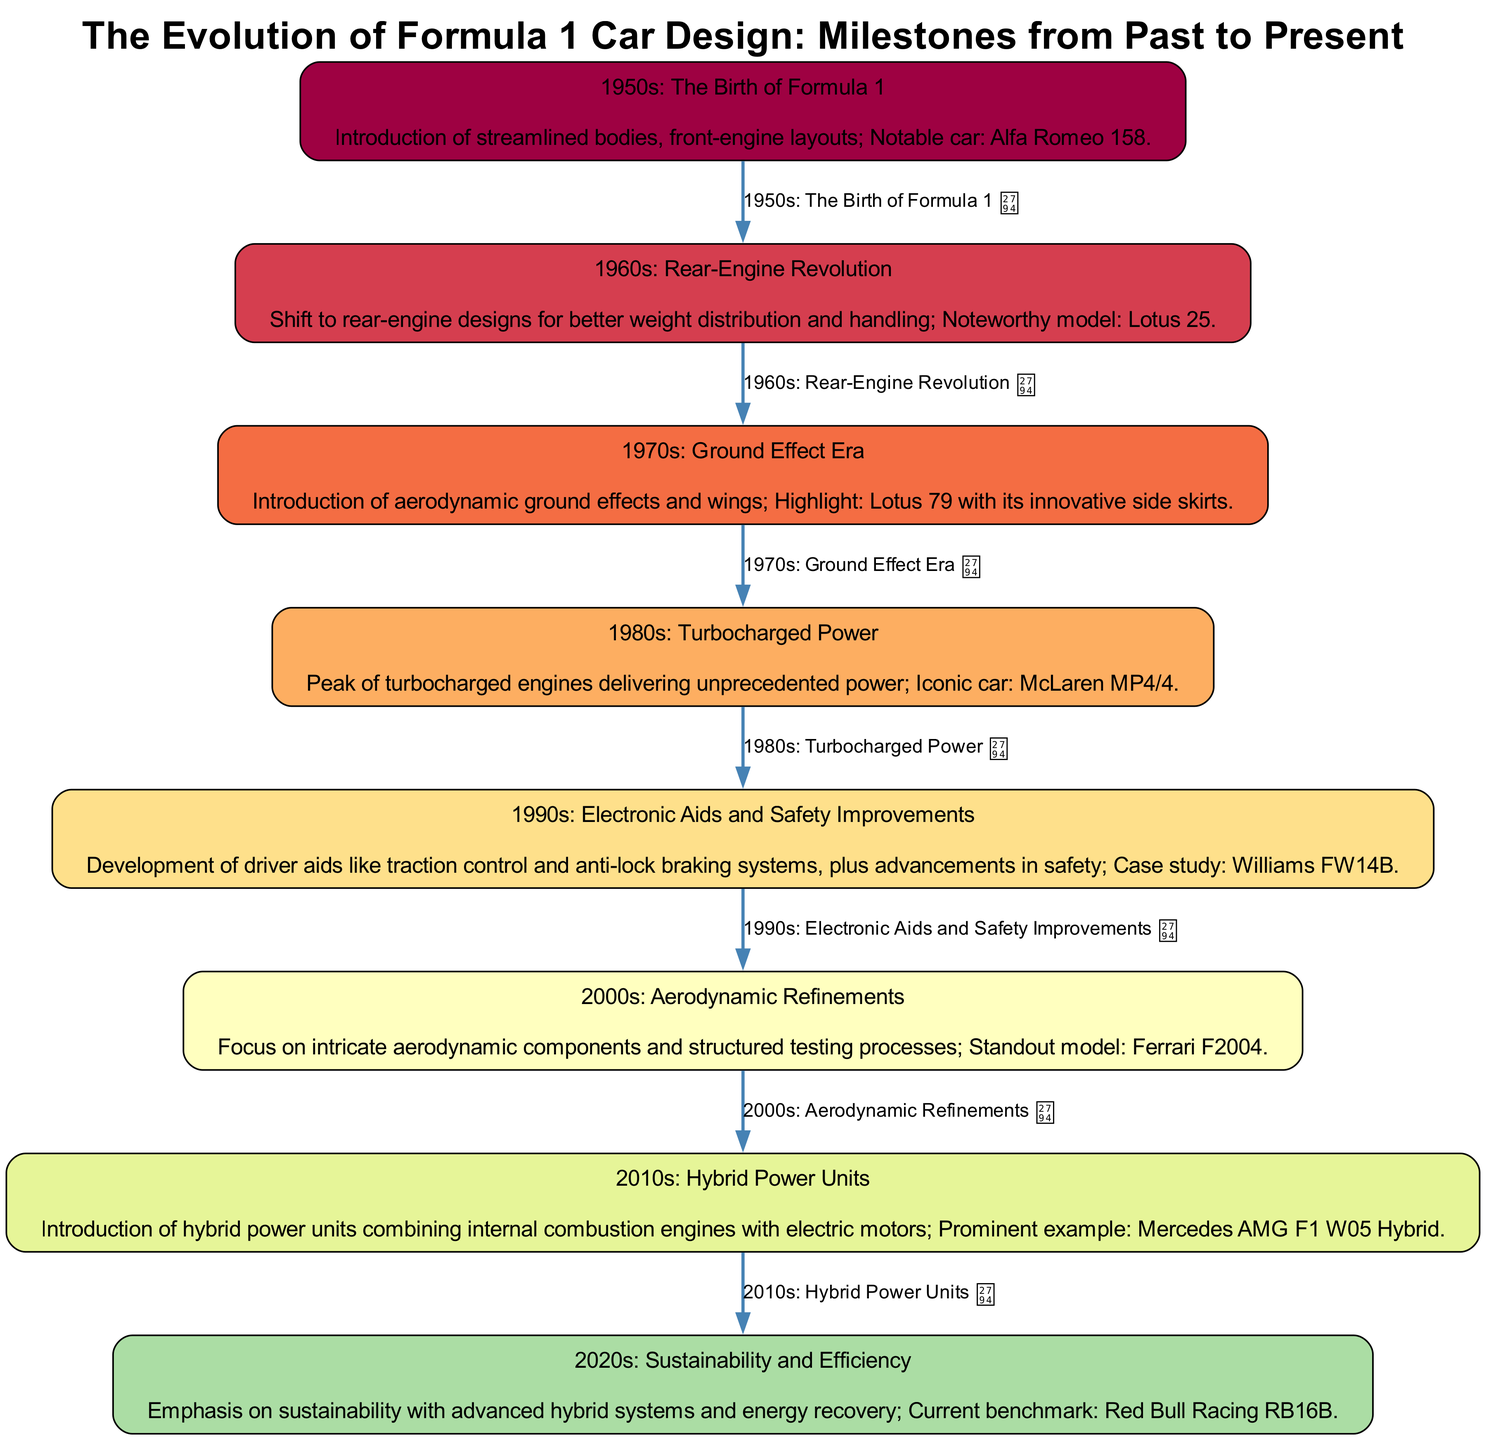What's the first milestone in the evolution of Formula 1 car design? The first milestone is the "1950s: The Birth of Formula 1," which introduces streamlined bodies and front-engine layouts, exemplified by the Alfa Romeo 158.
Answer: 1950s: The Birth of Formula 1 How many milestones are presented in the diagram? The diagram presents a total of eight milestones that outline the evolution of Formula 1 car design from the 1950s to the 2020s.
Answer: Eight Which car is highlighted for the 1970s? The highlighted car for the 1970s is the Lotus 79, known for its innovative aerodynamic side skirts that contributed to the ground effect era.
Answer: Lotus 79 What change occurred in the 2010s regarding engine technology? In the 2010s, the introduction of hybrid power units combined internal combustion engines with electric motors.
Answer: Hybrid power units Which decade introduced turbocharged engines? The 1980s introduced turbocharged engines, showcasing unprecedented power in Formula 1 cars, notably with the McLaren MP4/4.
Answer: 1980s What is the key feature of the 1990s Formula 1 cars? The key feature of the 1990s was the development of electronic aids such as traction control and advancements in safety features.
Answer: Electronic aids and safety improvements Which car is associated with the ongoing emphasis on sustainability in the 2020s? The car associated with sustainability efforts in the 2020s is the Red Bull Racing RB16B, representing advanced hybrid systems.
Answer: Red Bull Racing RB16B How does the diagram show the relationship between the 1960s and the 1970s? The diagram shows an arrow connecting the 1960s and the 1970s milestones, indicating a progression from rear-engine designs to ground effect innovations.
Answer: Arrow connection What does the Lotus 25 illustrate about car design in the 1960s? The Lotus 25 illustrates the shift to rear-engine designs in the 1960s that improved weight distribution and enhanced handling in Formula 1 cars.
Answer: Rear-engine designs 